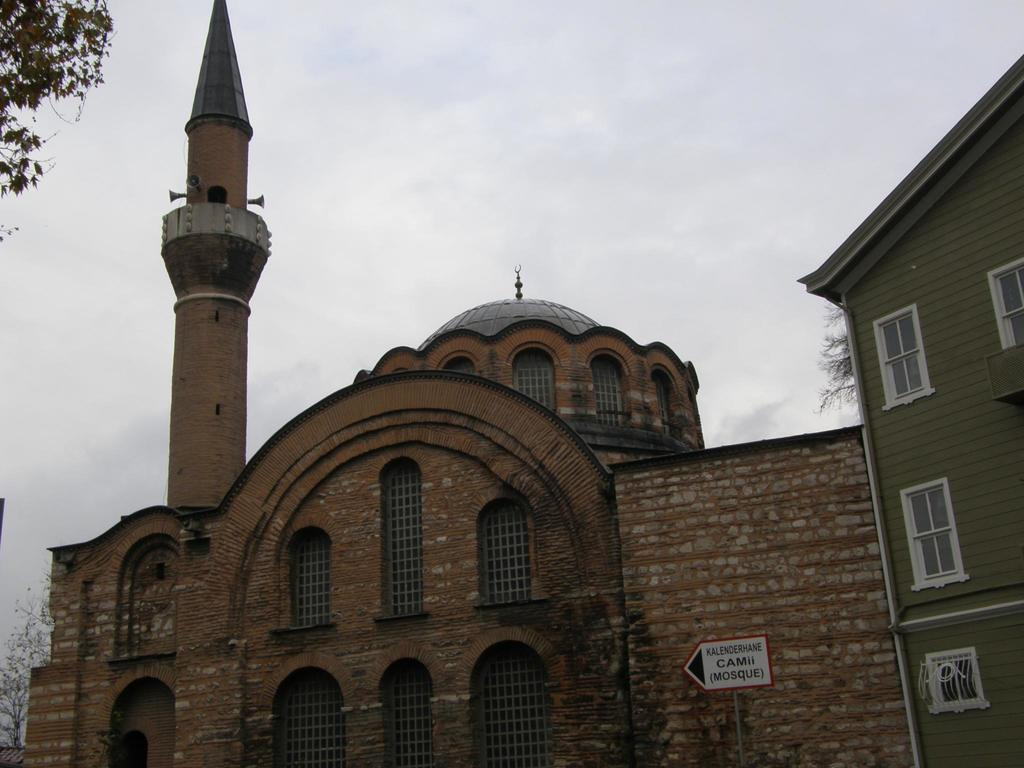What is the main structure in the center of the image? There is a mosque in the center of the image. What is located beside the mosque on the left side? There is a house beside the mosque on the left side. What type of vegetation can be seen on the left side of the image? There are trees on the left side of the image. What is visible at the top of the image? The sky is visible at the top of the image. How many minutes does it take for the minister to walk to the mosque with their friend in the image? There is no indication of time, walking, or the presence of a minister or friend in the image. 